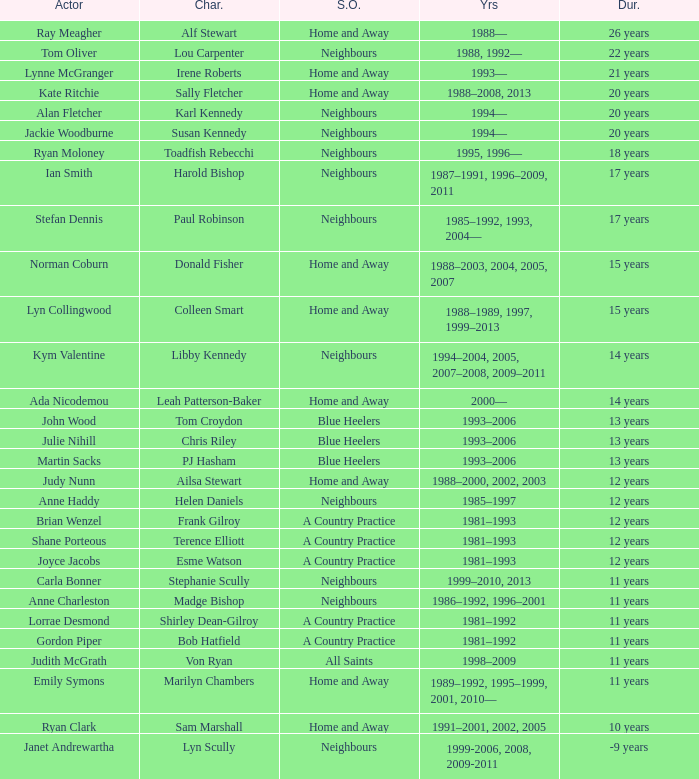How long did Joyce Jacobs portray her character on her show? 12 years. 